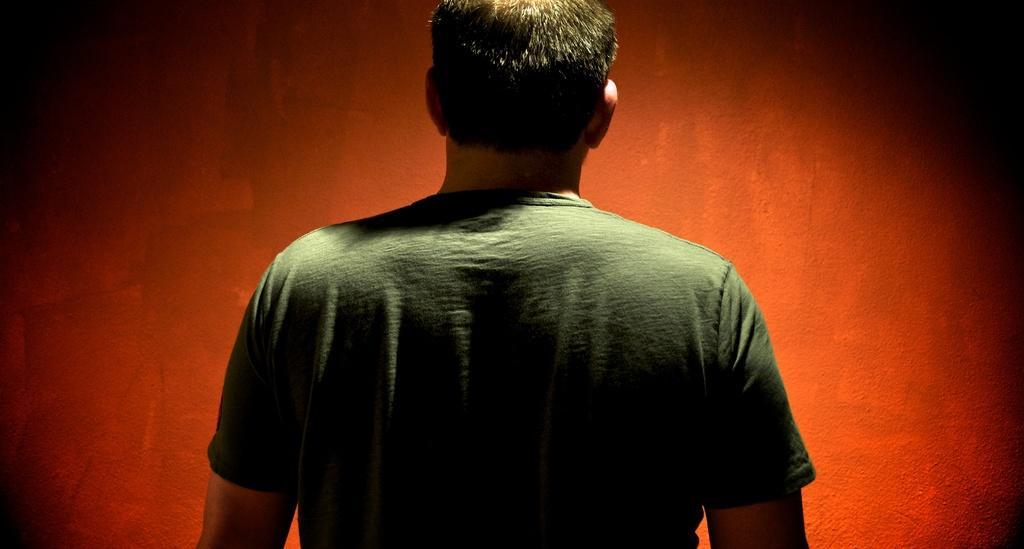How would you summarize this image in a sentence or two? In this picture I can observe a man in the middle of the picture. He is wearing green color T shirt. The background is in red color. 